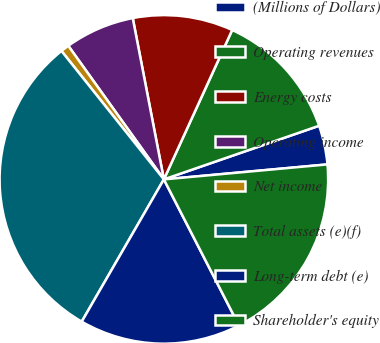Convert chart to OTSL. <chart><loc_0><loc_0><loc_500><loc_500><pie_chart><fcel>(Millions of Dollars)<fcel>Operating revenues<fcel>Energy costs<fcel>Operating income<fcel>Net income<fcel>Total assets (e)(f)<fcel>Long-term debt (e)<fcel>Shareholder's equity<nl><fcel>3.84%<fcel>12.88%<fcel>9.86%<fcel>6.85%<fcel>0.83%<fcel>30.95%<fcel>15.89%<fcel>18.9%<nl></chart> 